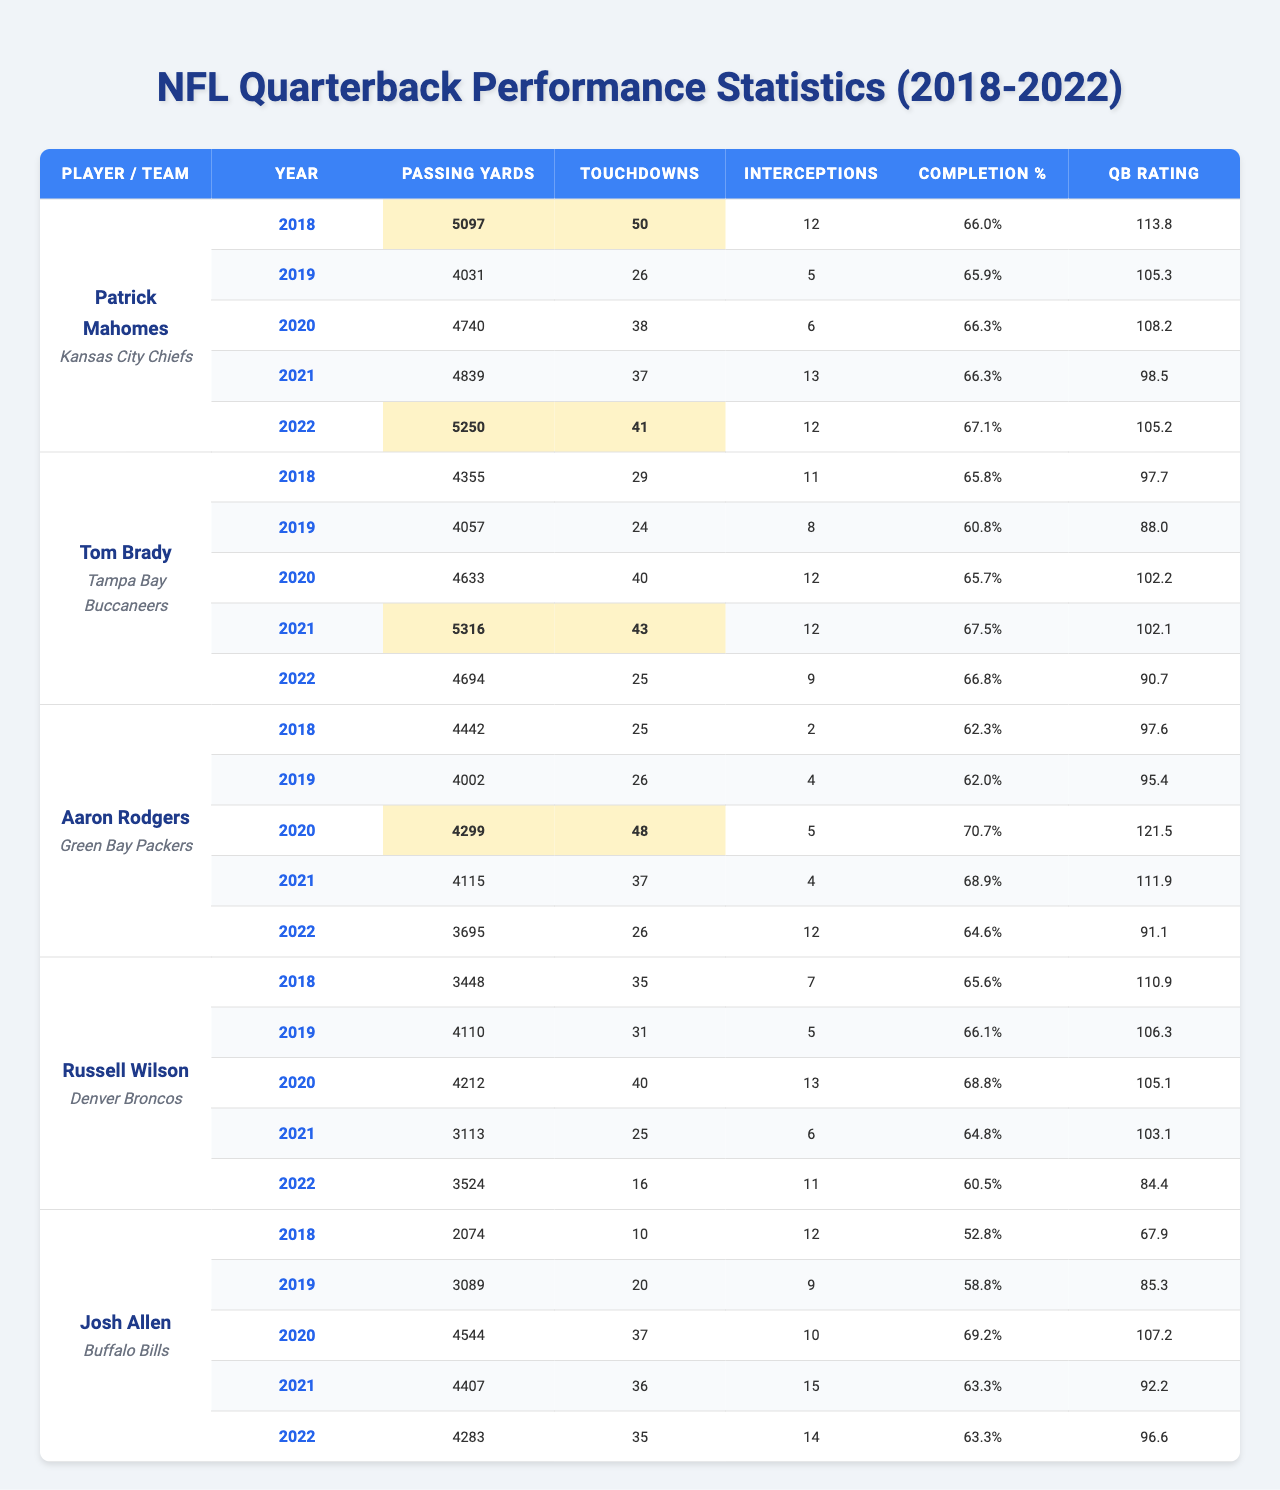What was Patrick Mahomes' highest Passing Yards in a season? Patrick Mahomes' highest Passing Yards came in the year 2018, where he threw for 5097 yards.
Answer: 5097 In which year did Tom Brady throw the most Touchdowns? Tom Brady threw the most Touchdowns in 2021, with a total of 43.
Answer: 43 How many Total Interceptions did Aaron Rodgers have from 2018 to 2022? Aaron Rodgers had 2 (2018) + 4 (2019) + 5 (2020) + 4 (2021) + 12 (2022) = 27 Total Interceptions.
Answer: 27 What was the Completion Percentage of Russell Wilson in 2019? In 2019, Russell Wilson's Completion Percentage was 66.1%.
Answer: 66.1% Did Josh Allen have more Passing Yards in 2021 or 2022? In 2021, Josh Allen had 4407 Passing Yards, while in 2022 he had 4283 Passing Yards. Thus, he had more in 2021.
Answer: More in 2021 What is the average Passing Yards for all players in the year 2020? The total Passing Yards in 2020 for all players is (4740 + 4633 + 4299 + 4212 + 4544) = 22128. There are 5 players, so the average is 22128 / 5 = 4425.6.
Answer: 4425.6 Which player had the best QBRating in 2020? In 2020, Aaron Rodgers had the best QBRating of 121.5.
Answer: 121.5 How many years did Patrick Mahomes have a QBRating over 110? Patrick Mahomes had a QBRating over 110 in 2018 (113.8), 2020 (108.2), and 2022 (105.2). That's two years total.
Answer: Two years Which quarterback had the lowest Completion Percentage in 2018? Josh Allen had the lowest Completion Percentage in 2018, with 52.8%.
Answer: 52.8% What was the difference in Touchdowns between the best and worst year for Russell Wilson? Russell Wilson had 35 Touchdowns in 2018 and only 16 in 2022. The difference is 35 - 16 = 19 Touchdowns.
Answer: 19 Touchdowns Did any quarterback throw for more than 5000 yards in more than one season? No, only Patrick Mahomes threw for over 5000 yards, and he did this in 2018 and 2022.
Answer: Yes, Patrick Mahomes 